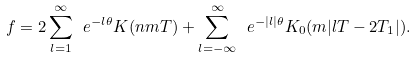<formula> <loc_0><loc_0><loc_500><loc_500>f = 2 \sum _ { l = 1 } ^ { \infty } \ e ^ { - l \theta } K ( n m T ) + \sum _ { l = - \infty } ^ { \infty } \ e ^ { - | l | \theta } K _ { 0 } ( m | l T - 2 T _ { 1 } | ) .</formula> 